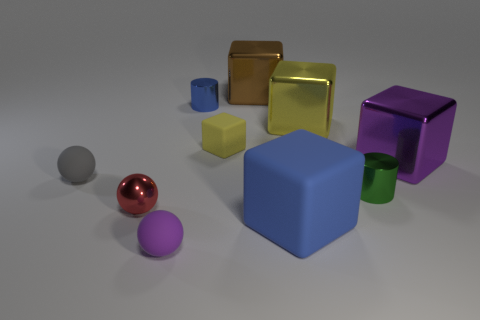What number of other objects are there of the same color as the small metal ball?
Keep it short and to the point. 0. What is the color of the tiny block?
Provide a short and direct response. Yellow. What size is the matte cube behind the purple object that is behind the small rubber object in front of the gray rubber object?
Offer a terse response. Small. There is a green cylinder that is the same size as the blue shiny thing; what is its material?
Offer a very short reply. Metal. Is there a gray sphere of the same size as the red metallic thing?
Your answer should be very brief. Yes. There is a yellow thing that is behind the yellow matte object; is its size the same as the brown thing?
Give a very brief answer. Yes. What is the shape of the big object that is to the left of the yellow metallic thing and behind the tiny yellow object?
Provide a succinct answer. Cube. Is the number of small rubber objects that are on the right side of the tiny red sphere greater than the number of small red matte things?
Keep it short and to the point. Yes. The yellow thing that is the same material as the tiny gray thing is what size?
Ensure brevity in your answer.  Small. What number of large rubber cubes are the same color as the small matte cube?
Keep it short and to the point. 0. 